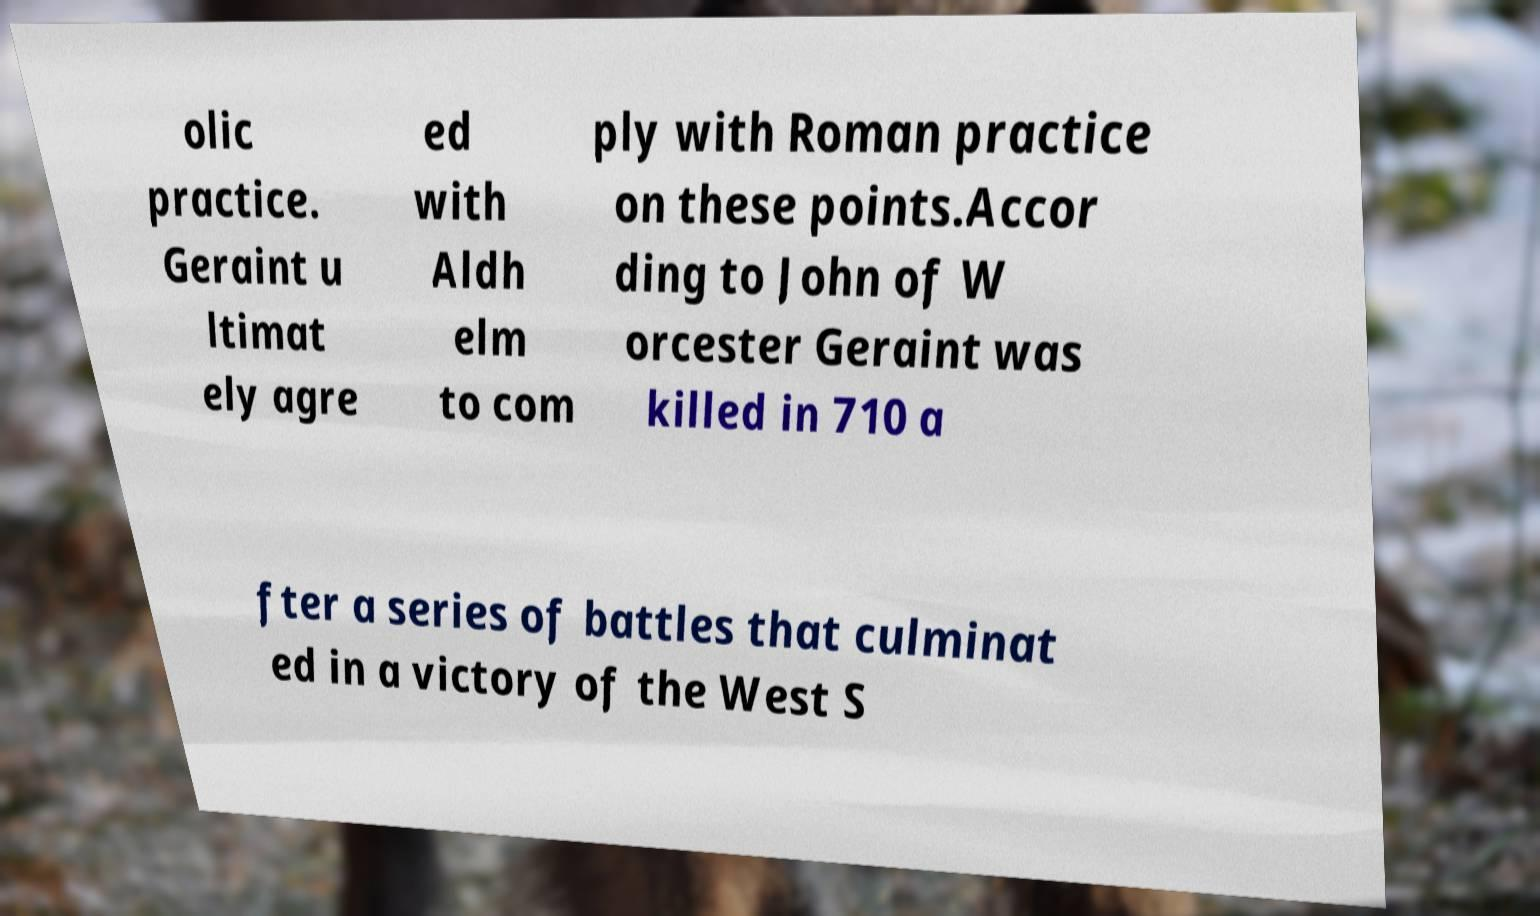What messages or text are displayed in this image? I need them in a readable, typed format. olic practice. Geraint u ltimat ely agre ed with Aldh elm to com ply with Roman practice on these points.Accor ding to John of W orcester Geraint was killed in 710 a fter a series of battles that culminat ed in a victory of the West S 